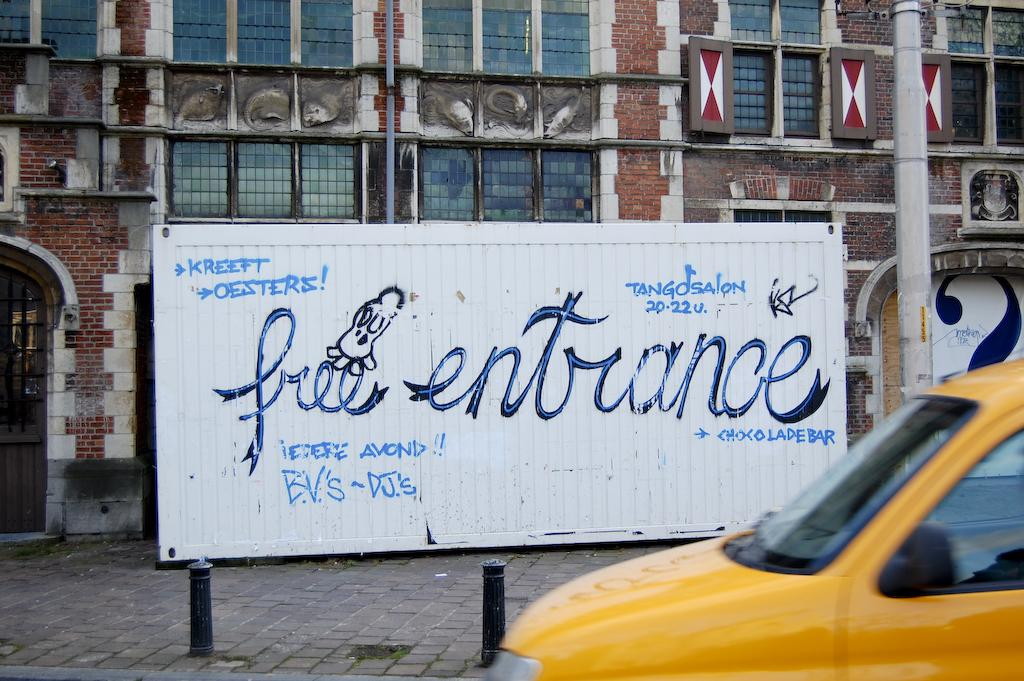<image>
Offer a succinct explanation of the picture presented. a sign that says free entrance on it 